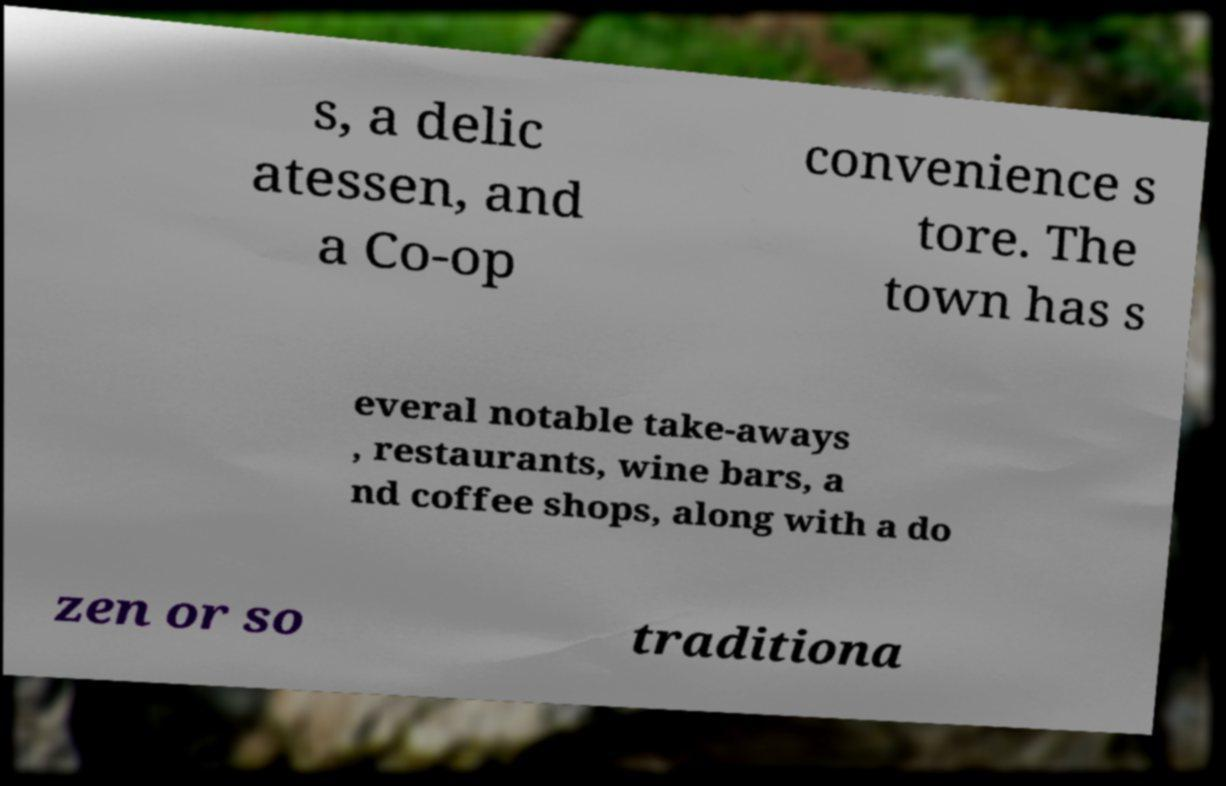Please identify and transcribe the text found in this image. s, a delic atessen, and a Co-op convenience s tore. The town has s everal notable take-aways , restaurants, wine bars, a nd coffee shops, along with a do zen or so traditiona 